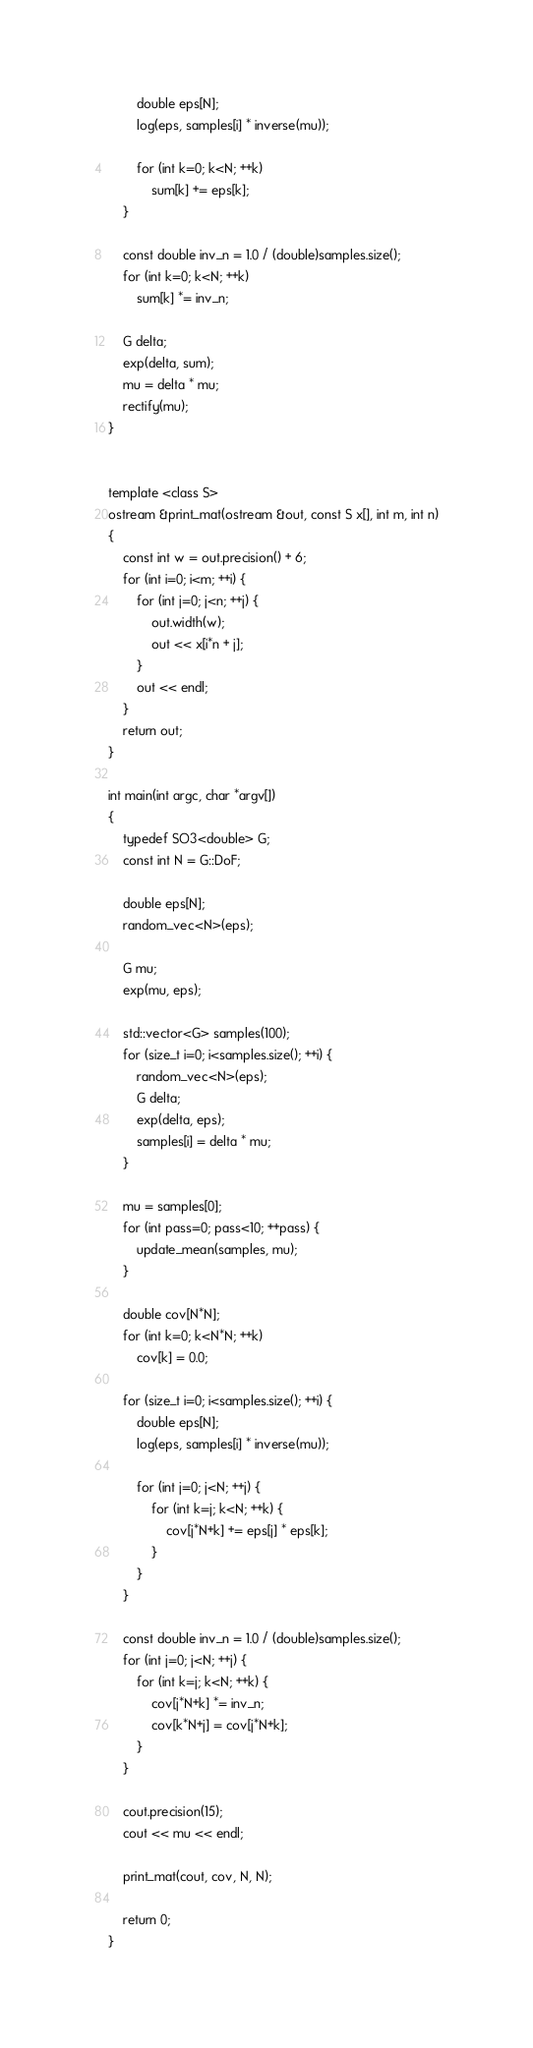<code> <loc_0><loc_0><loc_500><loc_500><_C++_>        double eps[N];
        log(eps, samples[i] * inverse(mu));

        for (int k=0; k<N; ++k)
            sum[k] += eps[k];
    }

    const double inv_n = 1.0 / (double)samples.size();
    for (int k=0; k<N; ++k)
        sum[k] *= inv_n;

    G delta;
    exp(delta, sum);
    mu = delta * mu;
    rectify(mu);
}


template <class S>
ostream &print_mat(ostream &out, const S x[], int m, int n)
{
    const int w = out.precision() + 6;
    for (int i=0; i<m; ++i) {
        for (int j=0; j<n; ++j) {
            out.width(w);
            out << x[i*n + j];
        }
        out << endl;
    }
    return out;
}

int main(int argc, char *argv[])
{
    typedef SO3<double> G;
    const int N = G::DoF;
    
    double eps[N];
    random_vec<N>(eps);
    
    G mu;    
    exp(mu, eps);

    std::vector<G> samples(100);
    for (size_t i=0; i<samples.size(); ++i) {
        random_vec<N>(eps);
        G delta;
        exp(delta, eps);
        samples[i] = delta * mu;        
    }

    mu = samples[0];
    for (int pass=0; pass<10; ++pass) {
        update_mean(samples, mu);
    }

    double cov[N*N];
    for (int k=0; k<N*N; ++k)
        cov[k] = 0.0;

    for (size_t i=0; i<samples.size(); ++i) {
        double eps[N];
        log(eps, samples[i] * inverse(mu));

        for (int j=0; j<N; ++j) {
            for (int k=j; k<N; ++k) {
                cov[j*N+k] += eps[j] * eps[k];
            }
        }
    }

    const double inv_n = 1.0 / (double)samples.size();
    for (int j=0; j<N; ++j) {
        for (int k=j; k<N; ++k) {
            cov[j*N+k] *= inv_n;
            cov[k*N+j] = cov[j*N+k];
        }
    }

    cout.precision(15);
    cout << mu << endl;
    
    print_mat(cout, cov, N, N);
    
    return 0;
}
</code> 